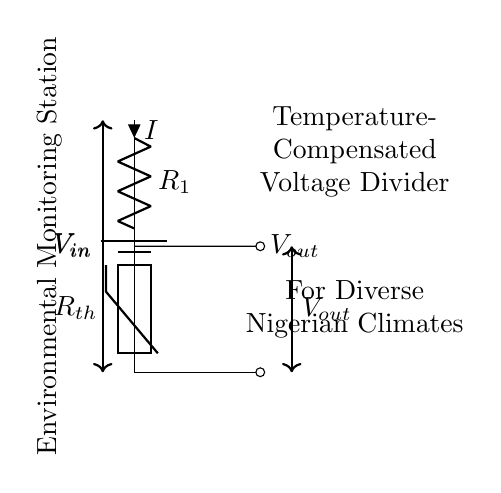What is the input voltage in this circuit? The input voltage, denoted as V_{in}, is represented at the top of the circuit diagram where the battery symbol is shown. This indicates the source of voltage for the voltage divider.
Answer: V_{in} What type of resistor is used in this voltage divider? The circuit diagram indicates that a thermistor, a type of temperature-dependent resistor, is connected as R_{th} in the voltage divider. This is crucial for temperature compensation in the monitoring system.
Answer: Thermistor What is the expected output voltage according to the schematic? The output voltage, labeled V_{out}, can be obtained from the voltage division across the resistors in the circuit setup. The specific value isn’t given, but it's the voltage measured at the output node.
Answer: V_{out} What does the current (I) represent in the circuit? The current I is indicated next to the resistor R_{1} and signifies the flow of electrical charge through the circuit. Its direction is from the input voltage toward the output voltage, showing the current's path.
Answer: Current How does the thermistor affect the voltage output? The thermistor's resistance varies with temperature, thereby affecting the voltage across it. This change influences the V_{out} due to the nature of the voltage divider formula, which is dependent on the ratio of R_{1} and R_{th}.
Answer: Voltage output What type of application is this circuit used for? The labels on the circuit diagram indicate that this voltage divider is designed for an environmental monitoring station, which suggests that it is used for sensing and recording environmental conditions.
Answer: Environmental monitoring What is the purpose of the temperature compensation in this voltage divider? Temperature compensation is necessary to ensure that the output voltage accurately reflects environmental temperature changes, allowing the monitoring station to function effectively across diverse climates in Nigeria. It stabilizes the reading against fluctuations.
Answer: Accuracy of readings 